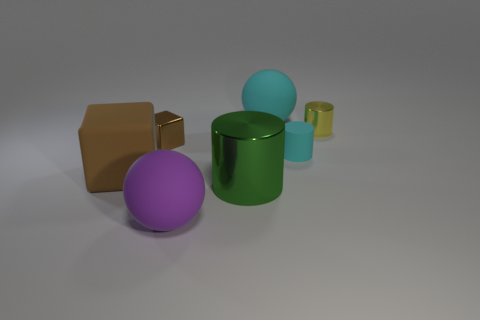Add 1 small brown shiny cubes. How many objects exist? 8 Subtract 3 cylinders. How many cylinders are left? 0 Subtract all large shiny cylinders. How many cylinders are left? 2 Subtract all spheres. How many objects are left? 5 Subtract all cyan spheres. How many spheres are left? 1 Subtract 0 green cubes. How many objects are left? 7 Subtract all cyan spheres. Subtract all blue blocks. How many spheres are left? 1 Subtract all cyan cubes. How many purple balls are left? 1 Subtract all large red things. Subtract all tiny brown things. How many objects are left? 6 Add 7 tiny yellow objects. How many tiny yellow objects are left? 8 